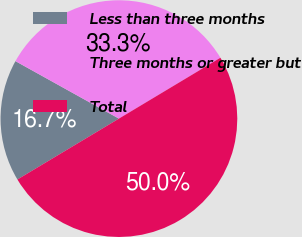Convert chart. <chart><loc_0><loc_0><loc_500><loc_500><pie_chart><fcel>Less than three months<fcel>Three months or greater but<fcel>Total<nl><fcel>16.67%<fcel>33.33%<fcel>50.0%<nl></chart> 